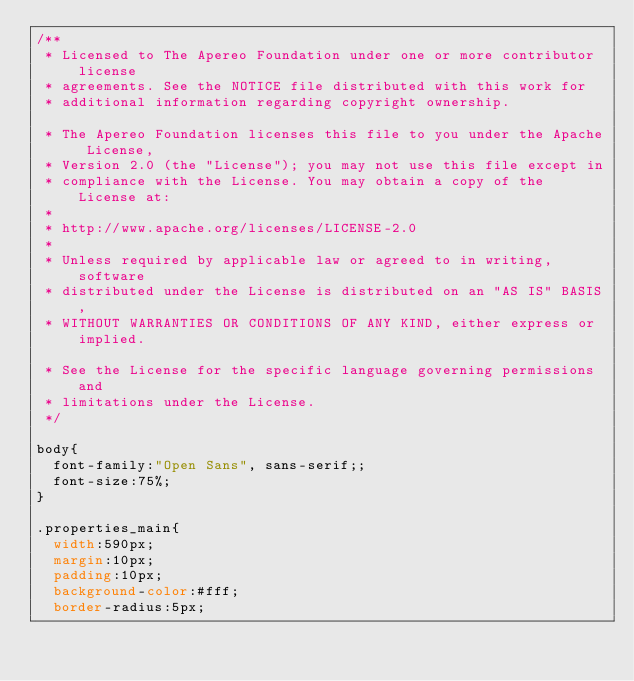Convert code to text. <code><loc_0><loc_0><loc_500><loc_500><_CSS_>/**
 * Licensed to The Apereo Foundation under one or more contributor license
 * agreements. See the NOTICE file distributed with this work for
 * additional information regarding copyright ownership.

 * The Apereo Foundation licenses this file to you under the Apache License,
 * Version 2.0 (the "License"); you may not use this file except in
 * compliance with the License. You may obtain a copy of the License at:
 *
 * http://www.apache.org/licenses/LICENSE-2.0
 * 
 * Unless required by applicable law or agreed to in writing, software
 * distributed under the License is distributed on an "AS IS" BASIS,
 * WITHOUT WARRANTIES OR CONDITIONS OF ANY KIND, either express or implied.

 * See the License for the specific language governing permissions and
 * limitations under the License.
 */
 
body{
	font-family:"Open Sans", sans-serif;;
	font-size:75%;
}

.properties_main{
	width:590px;
	margin:10px;
	padding:10px;
	background-color:#fff; 
	border-radius:5px;</code> 